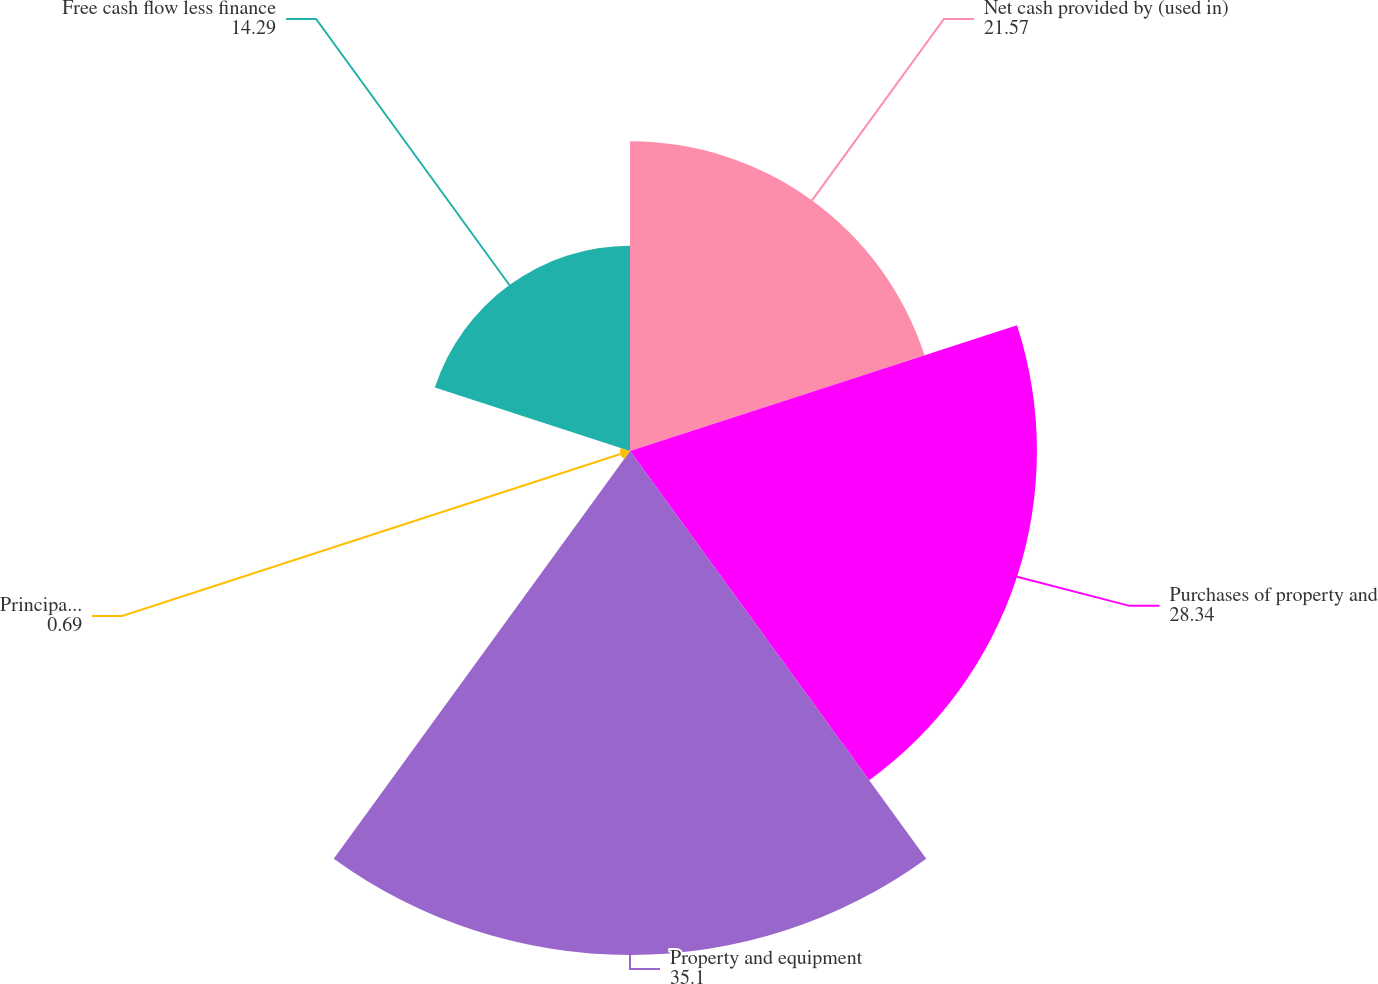<chart> <loc_0><loc_0><loc_500><loc_500><pie_chart><fcel>Net cash provided by (used in)<fcel>Purchases of property and<fcel>Property and equipment<fcel>Principal repayments of<fcel>Free cash flow less finance<nl><fcel>21.57%<fcel>28.34%<fcel>35.1%<fcel>0.69%<fcel>14.29%<nl></chart> 